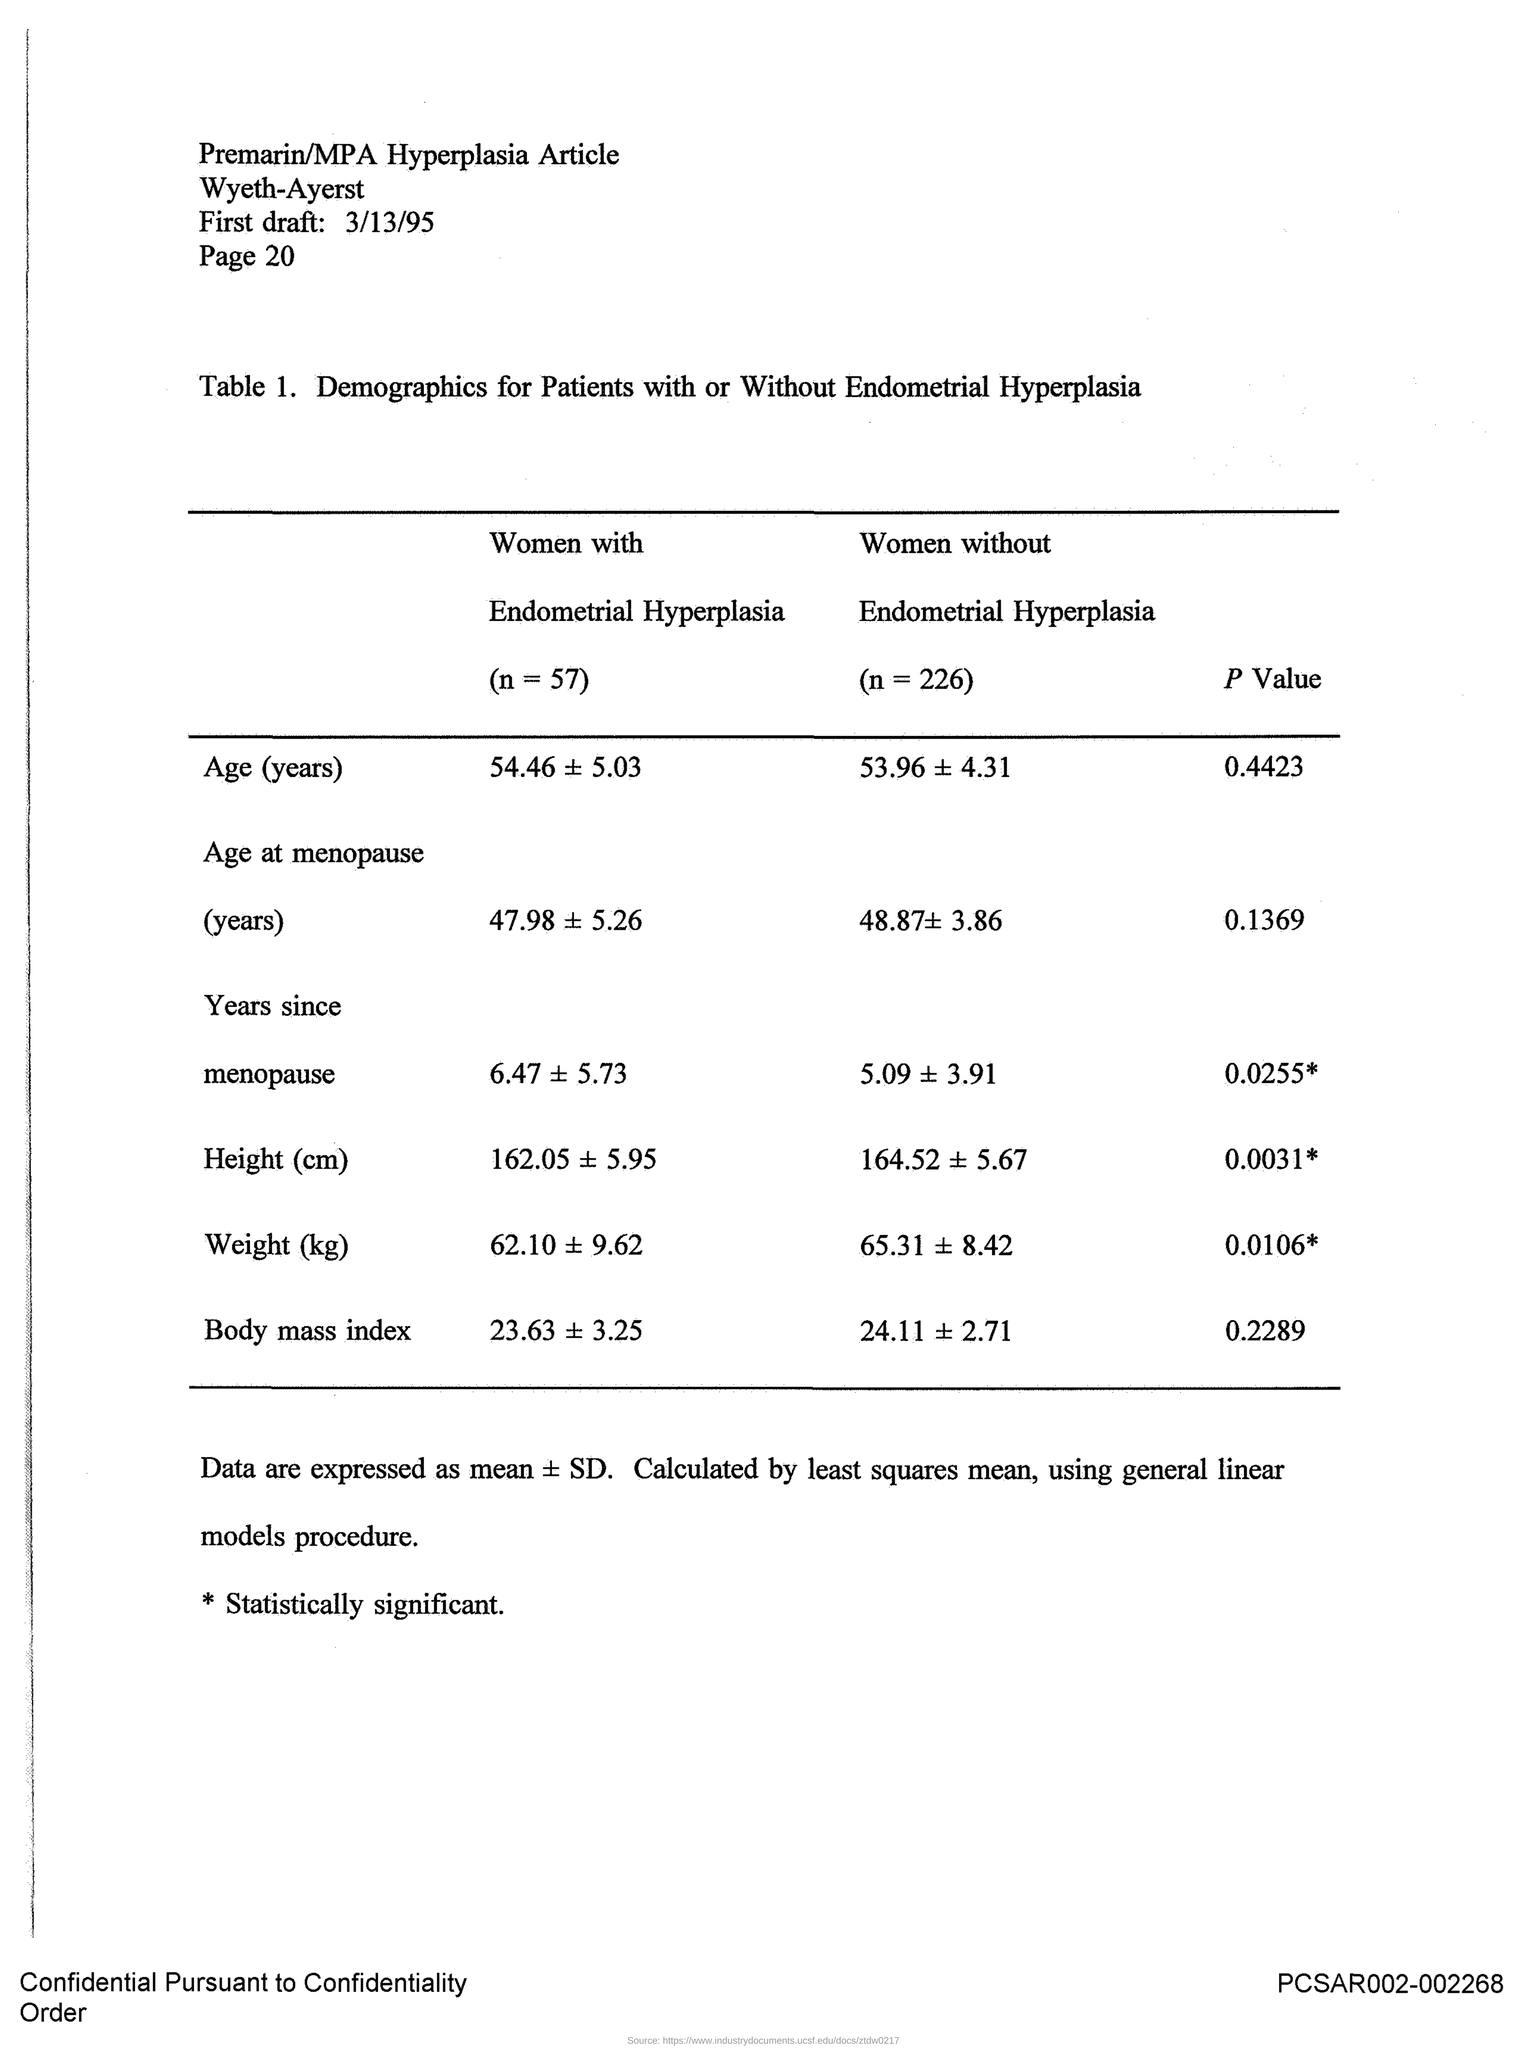What is the number of women with Endometrial Hyperplasia?
Give a very brief answer. 57. What is the number of woman without Endometrial Hyperplasia?
Your response must be concise. 226. What is the P value of Age?
Keep it short and to the point. 0.4423. What is the p value of body mass index?
Keep it short and to the point. 0.2289. 